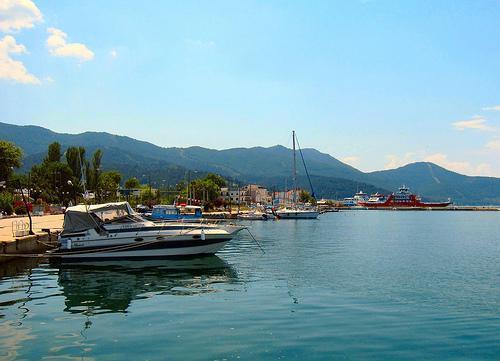How many bright blue boats are there?
Give a very brief answer. 1. 